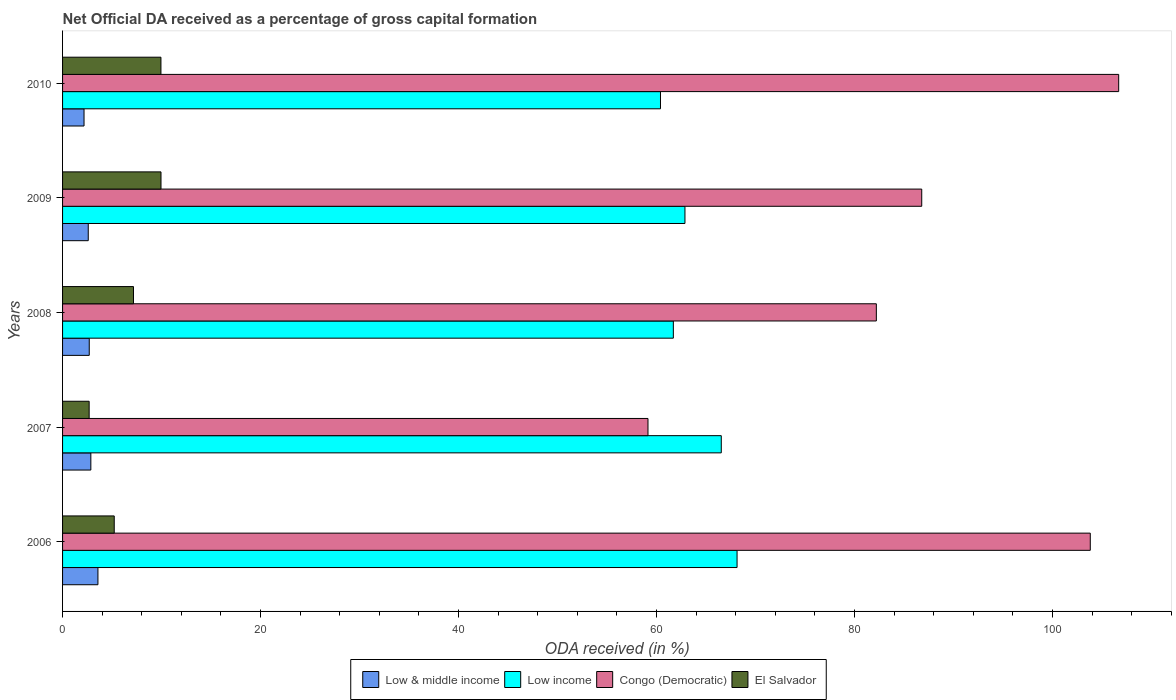How many groups of bars are there?
Ensure brevity in your answer.  5. Are the number of bars per tick equal to the number of legend labels?
Make the answer very short. Yes. Are the number of bars on each tick of the Y-axis equal?
Your answer should be very brief. Yes. How many bars are there on the 2nd tick from the top?
Ensure brevity in your answer.  4. What is the net ODA received in Congo (Democratic) in 2008?
Make the answer very short. 82.2. Across all years, what is the maximum net ODA received in El Salvador?
Ensure brevity in your answer.  9.94. Across all years, what is the minimum net ODA received in El Salvador?
Offer a terse response. 2.69. In which year was the net ODA received in Low & middle income maximum?
Your answer should be compact. 2006. In which year was the net ODA received in El Salvador minimum?
Your answer should be very brief. 2007. What is the total net ODA received in Low & middle income in the graph?
Provide a short and direct response. 13.89. What is the difference between the net ODA received in Low income in 2006 and that in 2010?
Make the answer very short. 7.74. What is the difference between the net ODA received in Low & middle income in 2006 and the net ODA received in El Salvador in 2008?
Make the answer very short. -3.59. What is the average net ODA received in El Salvador per year?
Give a very brief answer. 6.99. In the year 2009, what is the difference between the net ODA received in Low & middle income and net ODA received in Low income?
Keep it short and to the point. -60.27. In how many years, is the net ODA received in Low income greater than 12 %?
Provide a succinct answer. 5. What is the ratio of the net ODA received in Congo (Democratic) in 2006 to that in 2010?
Provide a succinct answer. 0.97. Is the net ODA received in Congo (Democratic) in 2007 less than that in 2008?
Offer a very short reply. Yes. Is the difference between the net ODA received in Low & middle income in 2006 and 2008 greater than the difference between the net ODA received in Low income in 2006 and 2008?
Ensure brevity in your answer.  No. What is the difference between the highest and the second highest net ODA received in Low & middle income?
Your answer should be compact. 0.72. What is the difference between the highest and the lowest net ODA received in Low income?
Make the answer very short. 7.74. What does the 3rd bar from the top in 2007 represents?
Keep it short and to the point. Low income. What does the 1st bar from the bottom in 2006 represents?
Make the answer very short. Low & middle income. Is it the case that in every year, the sum of the net ODA received in Low & middle income and net ODA received in Congo (Democratic) is greater than the net ODA received in Low income?
Ensure brevity in your answer.  No. Are all the bars in the graph horizontal?
Your answer should be compact. Yes. Are the values on the major ticks of X-axis written in scientific E-notation?
Ensure brevity in your answer.  No. Does the graph contain any zero values?
Give a very brief answer. No. Where does the legend appear in the graph?
Your answer should be compact. Bottom center. What is the title of the graph?
Give a very brief answer. Net Official DA received as a percentage of gross capital formation. What is the label or title of the X-axis?
Provide a short and direct response. ODA received (in %). What is the ODA received (in %) of Low & middle income in 2006?
Your answer should be compact. 3.57. What is the ODA received (in %) in Low income in 2006?
Provide a short and direct response. 68.13. What is the ODA received (in %) in Congo (Democratic) in 2006?
Give a very brief answer. 103.81. What is the ODA received (in %) of El Salvador in 2006?
Give a very brief answer. 5.22. What is the ODA received (in %) in Low & middle income in 2007?
Provide a short and direct response. 2.86. What is the ODA received (in %) of Low income in 2007?
Keep it short and to the point. 66.54. What is the ODA received (in %) in Congo (Democratic) in 2007?
Provide a succinct answer. 59.13. What is the ODA received (in %) of El Salvador in 2007?
Offer a terse response. 2.69. What is the ODA received (in %) of Low & middle income in 2008?
Ensure brevity in your answer.  2.7. What is the ODA received (in %) in Low income in 2008?
Your answer should be compact. 61.69. What is the ODA received (in %) in Congo (Democratic) in 2008?
Make the answer very short. 82.2. What is the ODA received (in %) of El Salvador in 2008?
Ensure brevity in your answer.  7.16. What is the ODA received (in %) in Low & middle income in 2009?
Provide a succinct answer. 2.59. What is the ODA received (in %) of Low income in 2009?
Give a very brief answer. 62.87. What is the ODA received (in %) of Congo (Democratic) in 2009?
Ensure brevity in your answer.  86.78. What is the ODA received (in %) in El Salvador in 2009?
Offer a terse response. 9.94. What is the ODA received (in %) of Low & middle income in 2010?
Ensure brevity in your answer.  2.17. What is the ODA received (in %) of Low income in 2010?
Make the answer very short. 60.39. What is the ODA received (in %) of Congo (Democratic) in 2010?
Ensure brevity in your answer.  106.68. What is the ODA received (in %) in El Salvador in 2010?
Give a very brief answer. 9.94. Across all years, what is the maximum ODA received (in %) of Low & middle income?
Your response must be concise. 3.57. Across all years, what is the maximum ODA received (in %) of Low income?
Keep it short and to the point. 68.13. Across all years, what is the maximum ODA received (in %) of Congo (Democratic)?
Provide a short and direct response. 106.68. Across all years, what is the maximum ODA received (in %) in El Salvador?
Provide a succinct answer. 9.94. Across all years, what is the minimum ODA received (in %) in Low & middle income?
Your response must be concise. 2.17. Across all years, what is the minimum ODA received (in %) in Low income?
Offer a terse response. 60.39. Across all years, what is the minimum ODA received (in %) of Congo (Democratic)?
Offer a very short reply. 59.13. Across all years, what is the minimum ODA received (in %) in El Salvador?
Offer a terse response. 2.69. What is the total ODA received (in %) in Low & middle income in the graph?
Make the answer very short. 13.89. What is the total ODA received (in %) in Low income in the graph?
Provide a short and direct response. 319.62. What is the total ODA received (in %) in Congo (Democratic) in the graph?
Your answer should be very brief. 438.6. What is the total ODA received (in %) of El Salvador in the graph?
Provide a succinct answer. 34.95. What is the difference between the ODA received (in %) in Low & middle income in 2006 and that in 2007?
Your answer should be compact. 0.72. What is the difference between the ODA received (in %) in Low income in 2006 and that in 2007?
Provide a short and direct response. 1.59. What is the difference between the ODA received (in %) in Congo (Democratic) in 2006 and that in 2007?
Provide a short and direct response. 44.67. What is the difference between the ODA received (in %) of El Salvador in 2006 and that in 2007?
Provide a short and direct response. 2.53. What is the difference between the ODA received (in %) of Low & middle income in 2006 and that in 2008?
Ensure brevity in your answer.  0.88. What is the difference between the ODA received (in %) in Low income in 2006 and that in 2008?
Your answer should be very brief. 6.44. What is the difference between the ODA received (in %) of Congo (Democratic) in 2006 and that in 2008?
Your answer should be very brief. 21.61. What is the difference between the ODA received (in %) in El Salvador in 2006 and that in 2008?
Provide a succinct answer. -1.94. What is the difference between the ODA received (in %) in Low & middle income in 2006 and that in 2009?
Give a very brief answer. 0.98. What is the difference between the ODA received (in %) in Low income in 2006 and that in 2009?
Offer a terse response. 5.26. What is the difference between the ODA received (in %) in Congo (Democratic) in 2006 and that in 2009?
Provide a short and direct response. 17.02. What is the difference between the ODA received (in %) in El Salvador in 2006 and that in 2009?
Your answer should be compact. -4.72. What is the difference between the ODA received (in %) in Low & middle income in 2006 and that in 2010?
Your answer should be very brief. 1.41. What is the difference between the ODA received (in %) in Low income in 2006 and that in 2010?
Your response must be concise. 7.74. What is the difference between the ODA received (in %) of Congo (Democratic) in 2006 and that in 2010?
Provide a succinct answer. -2.87. What is the difference between the ODA received (in %) of El Salvador in 2006 and that in 2010?
Provide a succinct answer. -4.72. What is the difference between the ODA received (in %) in Low & middle income in 2007 and that in 2008?
Your response must be concise. 0.16. What is the difference between the ODA received (in %) in Low income in 2007 and that in 2008?
Offer a terse response. 4.84. What is the difference between the ODA received (in %) in Congo (Democratic) in 2007 and that in 2008?
Offer a terse response. -23.07. What is the difference between the ODA received (in %) in El Salvador in 2007 and that in 2008?
Ensure brevity in your answer.  -4.48. What is the difference between the ODA received (in %) in Low & middle income in 2007 and that in 2009?
Offer a terse response. 0.26. What is the difference between the ODA received (in %) in Low income in 2007 and that in 2009?
Give a very brief answer. 3.67. What is the difference between the ODA received (in %) in Congo (Democratic) in 2007 and that in 2009?
Your answer should be compact. -27.65. What is the difference between the ODA received (in %) in El Salvador in 2007 and that in 2009?
Make the answer very short. -7.26. What is the difference between the ODA received (in %) of Low & middle income in 2007 and that in 2010?
Make the answer very short. 0.69. What is the difference between the ODA received (in %) in Low income in 2007 and that in 2010?
Make the answer very short. 6.14. What is the difference between the ODA received (in %) in Congo (Democratic) in 2007 and that in 2010?
Make the answer very short. -47.54. What is the difference between the ODA received (in %) of El Salvador in 2007 and that in 2010?
Provide a succinct answer. -7.25. What is the difference between the ODA received (in %) in Low & middle income in 2008 and that in 2009?
Ensure brevity in your answer.  0.1. What is the difference between the ODA received (in %) in Low income in 2008 and that in 2009?
Give a very brief answer. -1.17. What is the difference between the ODA received (in %) of Congo (Democratic) in 2008 and that in 2009?
Your answer should be very brief. -4.59. What is the difference between the ODA received (in %) in El Salvador in 2008 and that in 2009?
Give a very brief answer. -2.78. What is the difference between the ODA received (in %) in Low & middle income in 2008 and that in 2010?
Provide a short and direct response. 0.53. What is the difference between the ODA received (in %) in Low income in 2008 and that in 2010?
Give a very brief answer. 1.3. What is the difference between the ODA received (in %) in Congo (Democratic) in 2008 and that in 2010?
Provide a succinct answer. -24.48. What is the difference between the ODA received (in %) of El Salvador in 2008 and that in 2010?
Keep it short and to the point. -2.77. What is the difference between the ODA received (in %) in Low & middle income in 2009 and that in 2010?
Your answer should be compact. 0.43. What is the difference between the ODA received (in %) in Low income in 2009 and that in 2010?
Your answer should be compact. 2.47. What is the difference between the ODA received (in %) in Congo (Democratic) in 2009 and that in 2010?
Give a very brief answer. -19.89. What is the difference between the ODA received (in %) of El Salvador in 2009 and that in 2010?
Offer a terse response. 0.01. What is the difference between the ODA received (in %) in Low & middle income in 2006 and the ODA received (in %) in Low income in 2007?
Your answer should be compact. -62.96. What is the difference between the ODA received (in %) in Low & middle income in 2006 and the ODA received (in %) in Congo (Democratic) in 2007?
Your response must be concise. -55.56. What is the difference between the ODA received (in %) in Low & middle income in 2006 and the ODA received (in %) in El Salvador in 2007?
Give a very brief answer. 0.89. What is the difference between the ODA received (in %) of Low income in 2006 and the ODA received (in %) of Congo (Democratic) in 2007?
Provide a succinct answer. 9. What is the difference between the ODA received (in %) of Low income in 2006 and the ODA received (in %) of El Salvador in 2007?
Offer a very short reply. 65.44. What is the difference between the ODA received (in %) in Congo (Democratic) in 2006 and the ODA received (in %) in El Salvador in 2007?
Offer a terse response. 101.12. What is the difference between the ODA received (in %) in Low & middle income in 2006 and the ODA received (in %) in Low income in 2008?
Offer a terse response. -58.12. What is the difference between the ODA received (in %) of Low & middle income in 2006 and the ODA received (in %) of Congo (Democratic) in 2008?
Your answer should be compact. -78.62. What is the difference between the ODA received (in %) in Low & middle income in 2006 and the ODA received (in %) in El Salvador in 2008?
Your answer should be compact. -3.59. What is the difference between the ODA received (in %) of Low income in 2006 and the ODA received (in %) of Congo (Democratic) in 2008?
Keep it short and to the point. -14.07. What is the difference between the ODA received (in %) in Low income in 2006 and the ODA received (in %) in El Salvador in 2008?
Offer a terse response. 60.97. What is the difference between the ODA received (in %) of Congo (Democratic) in 2006 and the ODA received (in %) of El Salvador in 2008?
Your answer should be compact. 96.64. What is the difference between the ODA received (in %) of Low & middle income in 2006 and the ODA received (in %) of Low income in 2009?
Offer a very short reply. -59.29. What is the difference between the ODA received (in %) in Low & middle income in 2006 and the ODA received (in %) in Congo (Democratic) in 2009?
Provide a succinct answer. -83.21. What is the difference between the ODA received (in %) of Low & middle income in 2006 and the ODA received (in %) of El Salvador in 2009?
Make the answer very short. -6.37. What is the difference between the ODA received (in %) in Low income in 2006 and the ODA received (in %) in Congo (Democratic) in 2009?
Ensure brevity in your answer.  -18.65. What is the difference between the ODA received (in %) in Low income in 2006 and the ODA received (in %) in El Salvador in 2009?
Provide a short and direct response. 58.19. What is the difference between the ODA received (in %) of Congo (Democratic) in 2006 and the ODA received (in %) of El Salvador in 2009?
Offer a very short reply. 93.87. What is the difference between the ODA received (in %) in Low & middle income in 2006 and the ODA received (in %) in Low income in 2010?
Your answer should be compact. -56.82. What is the difference between the ODA received (in %) in Low & middle income in 2006 and the ODA received (in %) in Congo (Democratic) in 2010?
Make the answer very short. -103.1. What is the difference between the ODA received (in %) of Low & middle income in 2006 and the ODA received (in %) of El Salvador in 2010?
Your response must be concise. -6.36. What is the difference between the ODA received (in %) of Low income in 2006 and the ODA received (in %) of Congo (Democratic) in 2010?
Offer a very short reply. -38.55. What is the difference between the ODA received (in %) in Low income in 2006 and the ODA received (in %) in El Salvador in 2010?
Keep it short and to the point. 58.19. What is the difference between the ODA received (in %) in Congo (Democratic) in 2006 and the ODA received (in %) in El Salvador in 2010?
Ensure brevity in your answer.  93.87. What is the difference between the ODA received (in %) in Low & middle income in 2007 and the ODA received (in %) in Low income in 2008?
Give a very brief answer. -58.84. What is the difference between the ODA received (in %) of Low & middle income in 2007 and the ODA received (in %) of Congo (Democratic) in 2008?
Keep it short and to the point. -79.34. What is the difference between the ODA received (in %) in Low & middle income in 2007 and the ODA received (in %) in El Salvador in 2008?
Provide a succinct answer. -4.31. What is the difference between the ODA received (in %) of Low income in 2007 and the ODA received (in %) of Congo (Democratic) in 2008?
Offer a very short reply. -15.66. What is the difference between the ODA received (in %) in Low income in 2007 and the ODA received (in %) in El Salvador in 2008?
Give a very brief answer. 59.37. What is the difference between the ODA received (in %) in Congo (Democratic) in 2007 and the ODA received (in %) in El Salvador in 2008?
Offer a terse response. 51.97. What is the difference between the ODA received (in %) in Low & middle income in 2007 and the ODA received (in %) in Low income in 2009?
Keep it short and to the point. -60.01. What is the difference between the ODA received (in %) of Low & middle income in 2007 and the ODA received (in %) of Congo (Democratic) in 2009?
Offer a terse response. -83.93. What is the difference between the ODA received (in %) of Low & middle income in 2007 and the ODA received (in %) of El Salvador in 2009?
Keep it short and to the point. -7.09. What is the difference between the ODA received (in %) in Low income in 2007 and the ODA received (in %) in Congo (Democratic) in 2009?
Provide a short and direct response. -20.25. What is the difference between the ODA received (in %) in Low income in 2007 and the ODA received (in %) in El Salvador in 2009?
Provide a short and direct response. 56.59. What is the difference between the ODA received (in %) of Congo (Democratic) in 2007 and the ODA received (in %) of El Salvador in 2009?
Provide a succinct answer. 49.19. What is the difference between the ODA received (in %) of Low & middle income in 2007 and the ODA received (in %) of Low income in 2010?
Ensure brevity in your answer.  -57.54. What is the difference between the ODA received (in %) of Low & middle income in 2007 and the ODA received (in %) of Congo (Democratic) in 2010?
Ensure brevity in your answer.  -103.82. What is the difference between the ODA received (in %) of Low & middle income in 2007 and the ODA received (in %) of El Salvador in 2010?
Offer a very short reply. -7.08. What is the difference between the ODA received (in %) in Low income in 2007 and the ODA received (in %) in Congo (Democratic) in 2010?
Make the answer very short. -40.14. What is the difference between the ODA received (in %) of Low income in 2007 and the ODA received (in %) of El Salvador in 2010?
Offer a terse response. 56.6. What is the difference between the ODA received (in %) in Congo (Democratic) in 2007 and the ODA received (in %) in El Salvador in 2010?
Offer a very short reply. 49.2. What is the difference between the ODA received (in %) in Low & middle income in 2008 and the ODA received (in %) in Low income in 2009?
Your answer should be very brief. -60.17. What is the difference between the ODA received (in %) in Low & middle income in 2008 and the ODA received (in %) in Congo (Democratic) in 2009?
Ensure brevity in your answer.  -84.09. What is the difference between the ODA received (in %) in Low & middle income in 2008 and the ODA received (in %) in El Salvador in 2009?
Provide a short and direct response. -7.25. What is the difference between the ODA received (in %) of Low income in 2008 and the ODA received (in %) of Congo (Democratic) in 2009?
Your answer should be very brief. -25.09. What is the difference between the ODA received (in %) of Low income in 2008 and the ODA received (in %) of El Salvador in 2009?
Ensure brevity in your answer.  51.75. What is the difference between the ODA received (in %) of Congo (Democratic) in 2008 and the ODA received (in %) of El Salvador in 2009?
Your answer should be very brief. 72.26. What is the difference between the ODA received (in %) of Low & middle income in 2008 and the ODA received (in %) of Low income in 2010?
Make the answer very short. -57.7. What is the difference between the ODA received (in %) of Low & middle income in 2008 and the ODA received (in %) of Congo (Democratic) in 2010?
Ensure brevity in your answer.  -103.98. What is the difference between the ODA received (in %) of Low & middle income in 2008 and the ODA received (in %) of El Salvador in 2010?
Your answer should be compact. -7.24. What is the difference between the ODA received (in %) of Low income in 2008 and the ODA received (in %) of Congo (Democratic) in 2010?
Your response must be concise. -44.98. What is the difference between the ODA received (in %) in Low income in 2008 and the ODA received (in %) in El Salvador in 2010?
Your answer should be compact. 51.76. What is the difference between the ODA received (in %) of Congo (Democratic) in 2008 and the ODA received (in %) of El Salvador in 2010?
Make the answer very short. 72.26. What is the difference between the ODA received (in %) in Low & middle income in 2009 and the ODA received (in %) in Low income in 2010?
Your answer should be compact. -57.8. What is the difference between the ODA received (in %) in Low & middle income in 2009 and the ODA received (in %) in Congo (Democratic) in 2010?
Your answer should be very brief. -104.08. What is the difference between the ODA received (in %) in Low & middle income in 2009 and the ODA received (in %) in El Salvador in 2010?
Offer a terse response. -7.34. What is the difference between the ODA received (in %) in Low income in 2009 and the ODA received (in %) in Congo (Democratic) in 2010?
Your response must be concise. -43.81. What is the difference between the ODA received (in %) of Low income in 2009 and the ODA received (in %) of El Salvador in 2010?
Provide a short and direct response. 52.93. What is the difference between the ODA received (in %) in Congo (Democratic) in 2009 and the ODA received (in %) in El Salvador in 2010?
Offer a very short reply. 76.85. What is the average ODA received (in %) of Low & middle income per year?
Ensure brevity in your answer.  2.78. What is the average ODA received (in %) of Low income per year?
Give a very brief answer. 63.92. What is the average ODA received (in %) in Congo (Democratic) per year?
Keep it short and to the point. 87.72. What is the average ODA received (in %) in El Salvador per year?
Make the answer very short. 6.99. In the year 2006, what is the difference between the ODA received (in %) of Low & middle income and ODA received (in %) of Low income?
Your answer should be compact. -64.56. In the year 2006, what is the difference between the ODA received (in %) of Low & middle income and ODA received (in %) of Congo (Democratic)?
Provide a short and direct response. -100.23. In the year 2006, what is the difference between the ODA received (in %) of Low & middle income and ODA received (in %) of El Salvador?
Provide a succinct answer. -1.65. In the year 2006, what is the difference between the ODA received (in %) in Low income and ODA received (in %) in Congo (Democratic)?
Ensure brevity in your answer.  -35.68. In the year 2006, what is the difference between the ODA received (in %) of Low income and ODA received (in %) of El Salvador?
Offer a very short reply. 62.91. In the year 2006, what is the difference between the ODA received (in %) of Congo (Democratic) and ODA received (in %) of El Salvador?
Offer a very short reply. 98.59. In the year 2007, what is the difference between the ODA received (in %) in Low & middle income and ODA received (in %) in Low income?
Keep it short and to the point. -63.68. In the year 2007, what is the difference between the ODA received (in %) in Low & middle income and ODA received (in %) in Congo (Democratic)?
Your answer should be compact. -56.28. In the year 2007, what is the difference between the ODA received (in %) in Low & middle income and ODA received (in %) in El Salvador?
Give a very brief answer. 0.17. In the year 2007, what is the difference between the ODA received (in %) in Low income and ODA received (in %) in Congo (Democratic)?
Give a very brief answer. 7.4. In the year 2007, what is the difference between the ODA received (in %) in Low income and ODA received (in %) in El Salvador?
Your response must be concise. 63.85. In the year 2007, what is the difference between the ODA received (in %) of Congo (Democratic) and ODA received (in %) of El Salvador?
Your answer should be very brief. 56.45. In the year 2008, what is the difference between the ODA received (in %) of Low & middle income and ODA received (in %) of Low income?
Provide a short and direct response. -59. In the year 2008, what is the difference between the ODA received (in %) in Low & middle income and ODA received (in %) in Congo (Democratic)?
Provide a short and direct response. -79.5. In the year 2008, what is the difference between the ODA received (in %) of Low & middle income and ODA received (in %) of El Salvador?
Make the answer very short. -4.47. In the year 2008, what is the difference between the ODA received (in %) in Low income and ODA received (in %) in Congo (Democratic)?
Ensure brevity in your answer.  -20.5. In the year 2008, what is the difference between the ODA received (in %) in Low income and ODA received (in %) in El Salvador?
Provide a succinct answer. 54.53. In the year 2008, what is the difference between the ODA received (in %) in Congo (Democratic) and ODA received (in %) in El Salvador?
Provide a succinct answer. 75.04. In the year 2009, what is the difference between the ODA received (in %) in Low & middle income and ODA received (in %) in Low income?
Ensure brevity in your answer.  -60.27. In the year 2009, what is the difference between the ODA received (in %) in Low & middle income and ODA received (in %) in Congo (Democratic)?
Give a very brief answer. -84.19. In the year 2009, what is the difference between the ODA received (in %) of Low & middle income and ODA received (in %) of El Salvador?
Offer a very short reply. -7.35. In the year 2009, what is the difference between the ODA received (in %) of Low income and ODA received (in %) of Congo (Democratic)?
Make the answer very short. -23.92. In the year 2009, what is the difference between the ODA received (in %) of Low income and ODA received (in %) of El Salvador?
Your answer should be very brief. 52.92. In the year 2009, what is the difference between the ODA received (in %) in Congo (Democratic) and ODA received (in %) in El Salvador?
Provide a short and direct response. 76.84. In the year 2010, what is the difference between the ODA received (in %) in Low & middle income and ODA received (in %) in Low income?
Offer a very short reply. -58.23. In the year 2010, what is the difference between the ODA received (in %) in Low & middle income and ODA received (in %) in Congo (Democratic)?
Give a very brief answer. -104.51. In the year 2010, what is the difference between the ODA received (in %) of Low & middle income and ODA received (in %) of El Salvador?
Make the answer very short. -7.77. In the year 2010, what is the difference between the ODA received (in %) of Low income and ODA received (in %) of Congo (Democratic)?
Your response must be concise. -46.28. In the year 2010, what is the difference between the ODA received (in %) of Low income and ODA received (in %) of El Salvador?
Give a very brief answer. 50.46. In the year 2010, what is the difference between the ODA received (in %) of Congo (Democratic) and ODA received (in %) of El Salvador?
Give a very brief answer. 96.74. What is the ratio of the ODA received (in %) in Low & middle income in 2006 to that in 2007?
Offer a very short reply. 1.25. What is the ratio of the ODA received (in %) of Low income in 2006 to that in 2007?
Offer a very short reply. 1.02. What is the ratio of the ODA received (in %) in Congo (Democratic) in 2006 to that in 2007?
Your answer should be very brief. 1.76. What is the ratio of the ODA received (in %) in El Salvador in 2006 to that in 2007?
Your answer should be compact. 1.94. What is the ratio of the ODA received (in %) of Low & middle income in 2006 to that in 2008?
Provide a short and direct response. 1.33. What is the ratio of the ODA received (in %) in Low income in 2006 to that in 2008?
Ensure brevity in your answer.  1.1. What is the ratio of the ODA received (in %) in Congo (Democratic) in 2006 to that in 2008?
Provide a succinct answer. 1.26. What is the ratio of the ODA received (in %) of El Salvador in 2006 to that in 2008?
Ensure brevity in your answer.  0.73. What is the ratio of the ODA received (in %) in Low & middle income in 2006 to that in 2009?
Provide a short and direct response. 1.38. What is the ratio of the ODA received (in %) in Low income in 2006 to that in 2009?
Provide a succinct answer. 1.08. What is the ratio of the ODA received (in %) of Congo (Democratic) in 2006 to that in 2009?
Provide a succinct answer. 1.2. What is the ratio of the ODA received (in %) of El Salvador in 2006 to that in 2009?
Offer a very short reply. 0.52. What is the ratio of the ODA received (in %) of Low & middle income in 2006 to that in 2010?
Give a very brief answer. 1.65. What is the ratio of the ODA received (in %) of Low income in 2006 to that in 2010?
Offer a very short reply. 1.13. What is the ratio of the ODA received (in %) of Congo (Democratic) in 2006 to that in 2010?
Provide a succinct answer. 0.97. What is the ratio of the ODA received (in %) of El Salvador in 2006 to that in 2010?
Ensure brevity in your answer.  0.53. What is the ratio of the ODA received (in %) of Low & middle income in 2007 to that in 2008?
Your answer should be compact. 1.06. What is the ratio of the ODA received (in %) of Low income in 2007 to that in 2008?
Offer a very short reply. 1.08. What is the ratio of the ODA received (in %) in Congo (Democratic) in 2007 to that in 2008?
Your answer should be very brief. 0.72. What is the ratio of the ODA received (in %) in El Salvador in 2007 to that in 2008?
Your answer should be compact. 0.37. What is the ratio of the ODA received (in %) in Low & middle income in 2007 to that in 2009?
Make the answer very short. 1.1. What is the ratio of the ODA received (in %) in Low income in 2007 to that in 2009?
Keep it short and to the point. 1.06. What is the ratio of the ODA received (in %) in Congo (Democratic) in 2007 to that in 2009?
Provide a short and direct response. 0.68. What is the ratio of the ODA received (in %) of El Salvador in 2007 to that in 2009?
Offer a very short reply. 0.27. What is the ratio of the ODA received (in %) in Low & middle income in 2007 to that in 2010?
Your response must be concise. 1.32. What is the ratio of the ODA received (in %) of Low income in 2007 to that in 2010?
Provide a succinct answer. 1.1. What is the ratio of the ODA received (in %) in Congo (Democratic) in 2007 to that in 2010?
Keep it short and to the point. 0.55. What is the ratio of the ODA received (in %) of El Salvador in 2007 to that in 2010?
Make the answer very short. 0.27. What is the ratio of the ODA received (in %) in Low & middle income in 2008 to that in 2009?
Your response must be concise. 1.04. What is the ratio of the ODA received (in %) in Low income in 2008 to that in 2009?
Offer a terse response. 0.98. What is the ratio of the ODA received (in %) in Congo (Democratic) in 2008 to that in 2009?
Offer a terse response. 0.95. What is the ratio of the ODA received (in %) of El Salvador in 2008 to that in 2009?
Provide a short and direct response. 0.72. What is the ratio of the ODA received (in %) of Low & middle income in 2008 to that in 2010?
Your answer should be very brief. 1.24. What is the ratio of the ODA received (in %) in Low income in 2008 to that in 2010?
Your answer should be very brief. 1.02. What is the ratio of the ODA received (in %) in Congo (Democratic) in 2008 to that in 2010?
Offer a terse response. 0.77. What is the ratio of the ODA received (in %) of El Salvador in 2008 to that in 2010?
Make the answer very short. 0.72. What is the ratio of the ODA received (in %) of Low & middle income in 2009 to that in 2010?
Your answer should be compact. 1.2. What is the ratio of the ODA received (in %) of Low income in 2009 to that in 2010?
Give a very brief answer. 1.04. What is the ratio of the ODA received (in %) in Congo (Democratic) in 2009 to that in 2010?
Offer a terse response. 0.81. What is the difference between the highest and the second highest ODA received (in %) in Low & middle income?
Provide a short and direct response. 0.72. What is the difference between the highest and the second highest ODA received (in %) in Low income?
Give a very brief answer. 1.59. What is the difference between the highest and the second highest ODA received (in %) of Congo (Democratic)?
Your response must be concise. 2.87. What is the difference between the highest and the second highest ODA received (in %) in El Salvador?
Give a very brief answer. 0.01. What is the difference between the highest and the lowest ODA received (in %) in Low & middle income?
Provide a short and direct response. 1.41. What is the difference between the highest and the lowest ODA received (in %) of Low income?
Your answer should be compact. 7.74. What is the difference between the highest and the lowest ODA received (in %) of Congo (Democratic)?
Offer a terse response. 47.54. What is the difference between the highest and the lowest ODA received (in %) in El Salvador?
Make the answer very short. 7.26. 